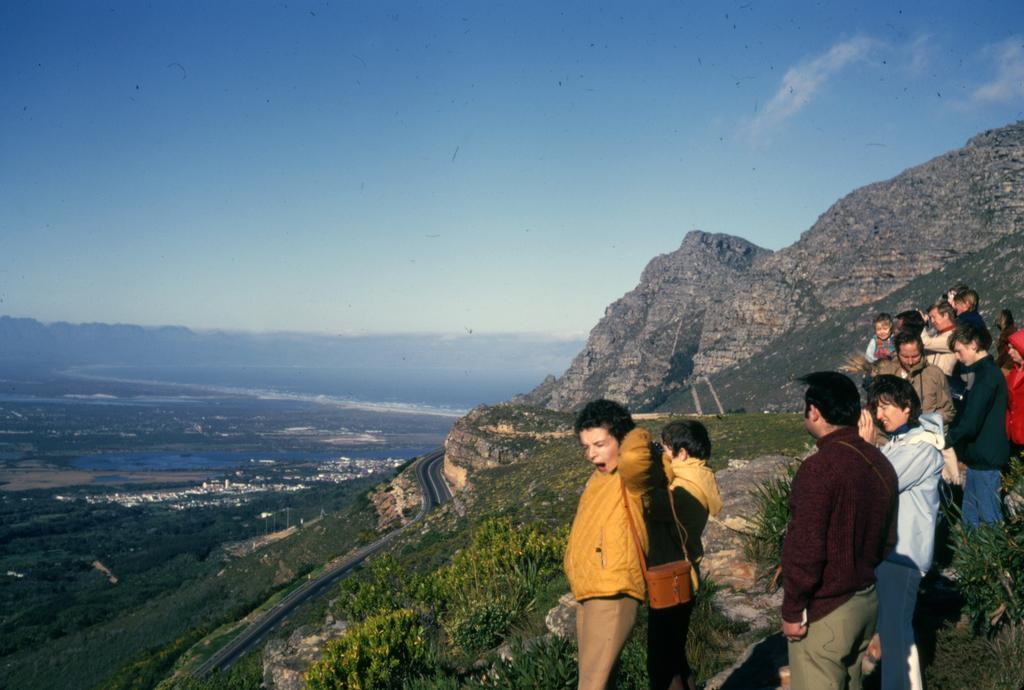Describe this image in one or two sentences. In this picture there is a beautiful view of the hill. On the top there is a group of a man and woman standing on the hill. Behind there is a big mountains with full of trees. 